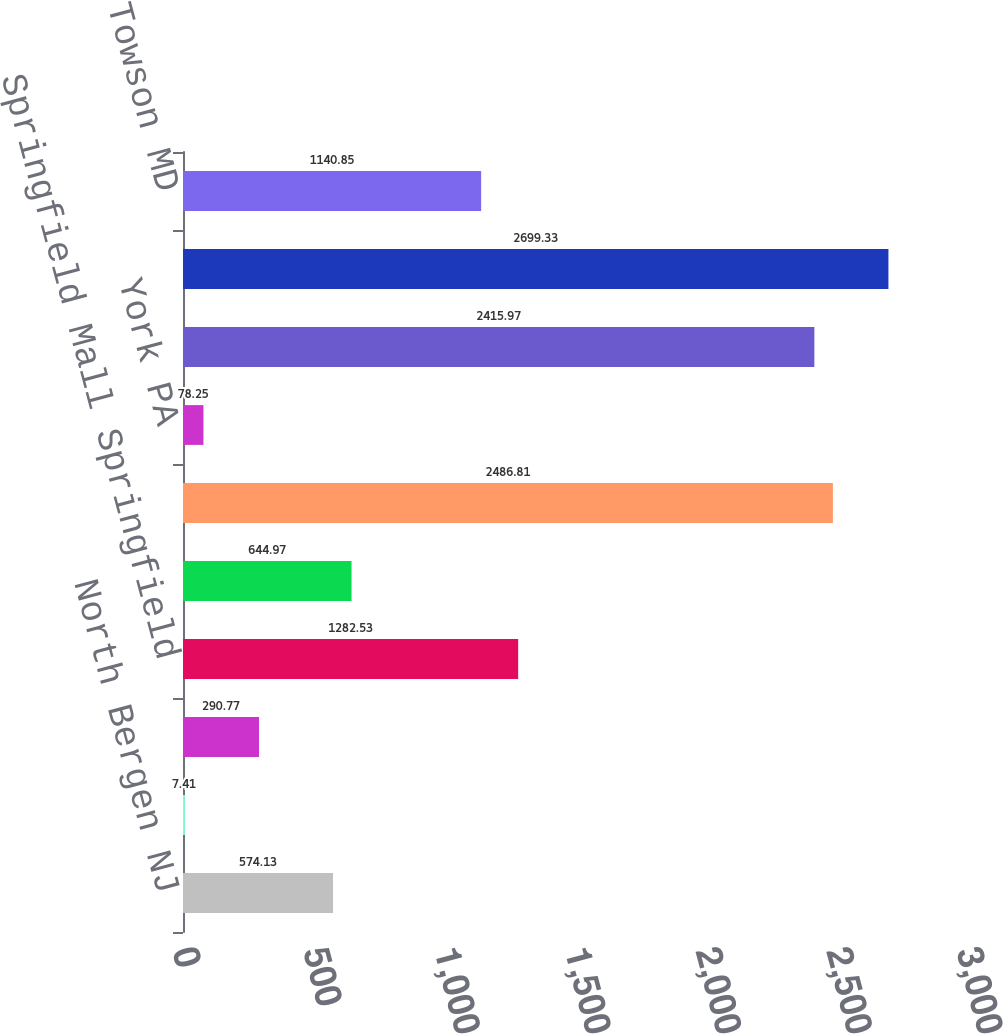Convert chart to OTSL. <chart><loc_0><loc_0><loc_500><loc_500><bar_chart><fcel>North Bergen NJ<fcel>Garfield NJ<fcel>Bricktown NJ<fcel>Springfield Mall Springfield<fcel>Totowa NJ<fcel>Green Acres Mall Valley Stream<fcel>York PA<fcel>Monmouth Mall Eatontown NJ<fcel>Montehiedra Mall Puerto Rico<fcel>Towson MD<nl><fcel>574.13<fcel>7.41<fcel>290.77<fcel>1282.53<fcel>644.97<fcel>2486.81<fcel>78.25<fcel>2415.97<fcel>2699.33<fcel>1140.85<nl></chart> 